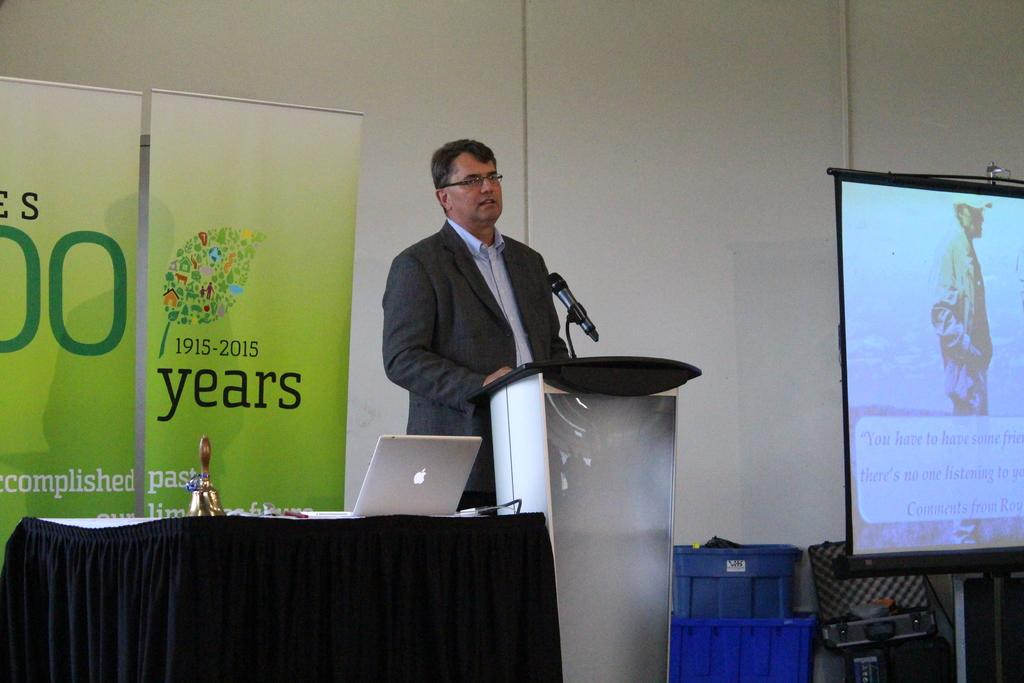<image>
Relay a brief, clear account of the picture shown. Man speaking at a podium in front of a banner displaying 1915-2015 100 years. 